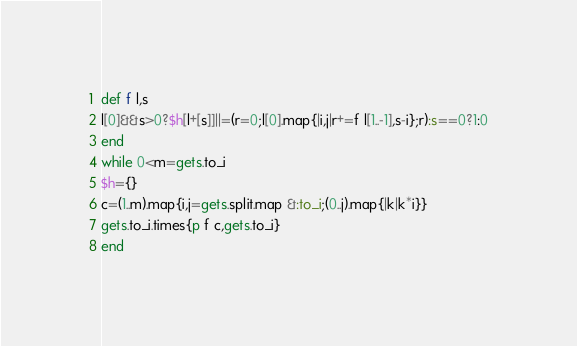<code> <loc_0><loc_0><loc_500><loc_500><_Ruby_>def f l,s
l[0]&&s>0?$h[l+[s]]||=(r=0;l[0].map{|i,j|r+=f l[1..-1],s-i};r):s==0?1:0
end
while 0<m=gets.to_i
$h={}
c=(1..m).map{i,j=gets.split.map &:to_i;(0..j).map{|k|k*i}}
gets.to_i.times{p f c,gets.to_i}
end</code> 